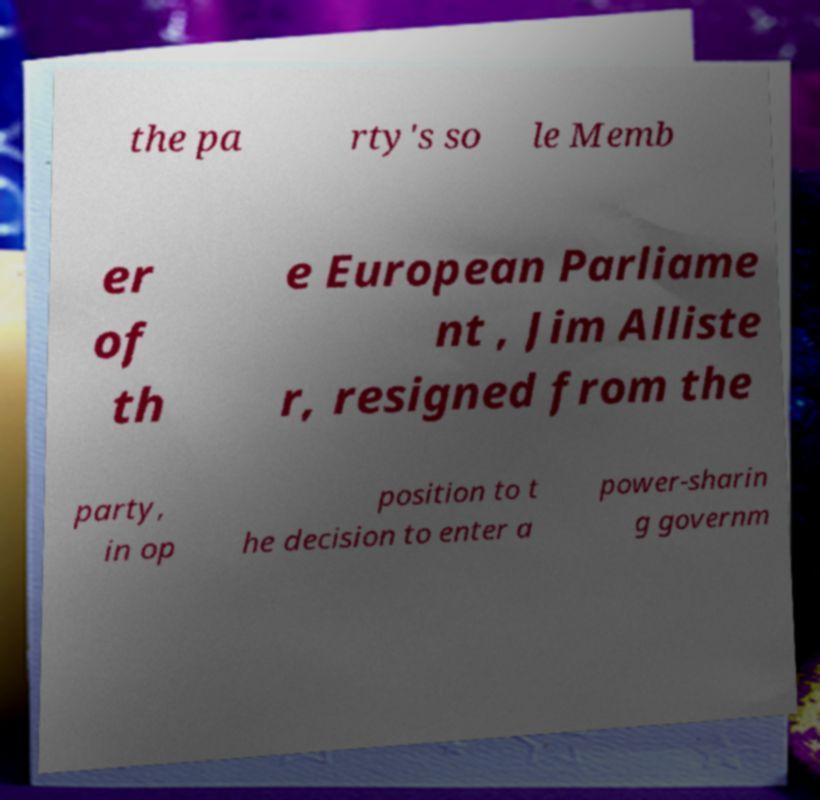I need the written content from this picture converted into text. Can you do that? the pa rty's so le Memb er of th e European Parliame nt , Jim Alliste r, resigned from the party, in op position to t he decision to enter a power-sharin g governm 